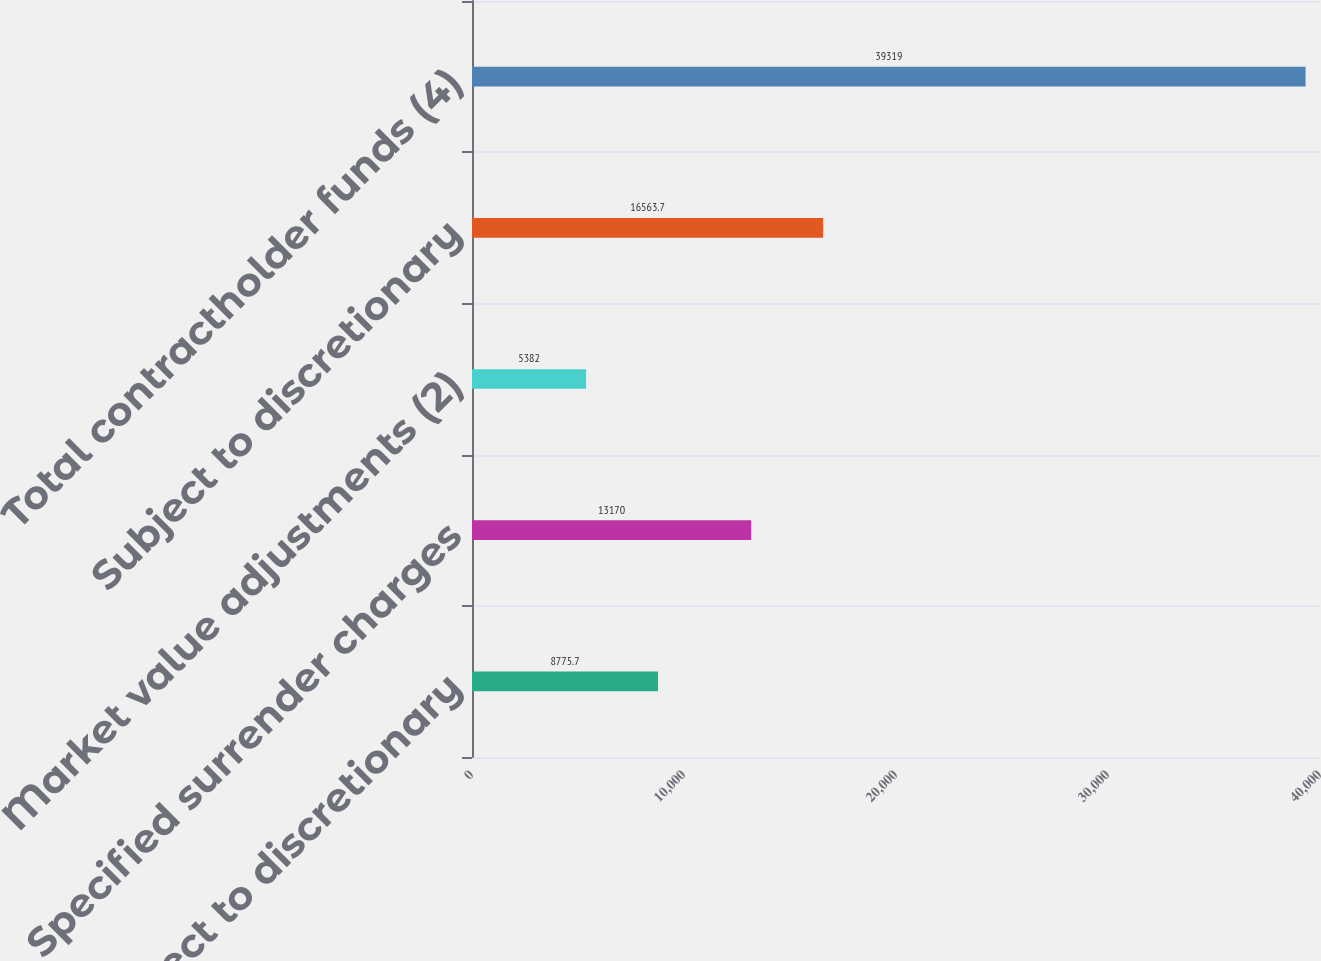Convert chart to OTSL. <chart><loc_0><loc_0><loc_500><loc_500><bar_chart><fcel>Not subject to discretionary<fcel>Specified surrender charges<fcel>Market value adjustments (2)<fcel>Subject to discretionary<fcel>Total contractholder funds (4)<nl><fcel>8775.7<fcel>13170<fcel>5382<fcel>16563.7<fcel>39319<nl></chart> 